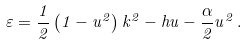<formula> <loc_0><loc_0><loc_500><loc_500>\varepsilon = \frac { 1 } { 2 } \left ( 1 - u ^ { 2 } \right ) k ^ { 2 } - h u - \frac { \alpha } { 2 } u ^ { 2 } \, .</formula> 